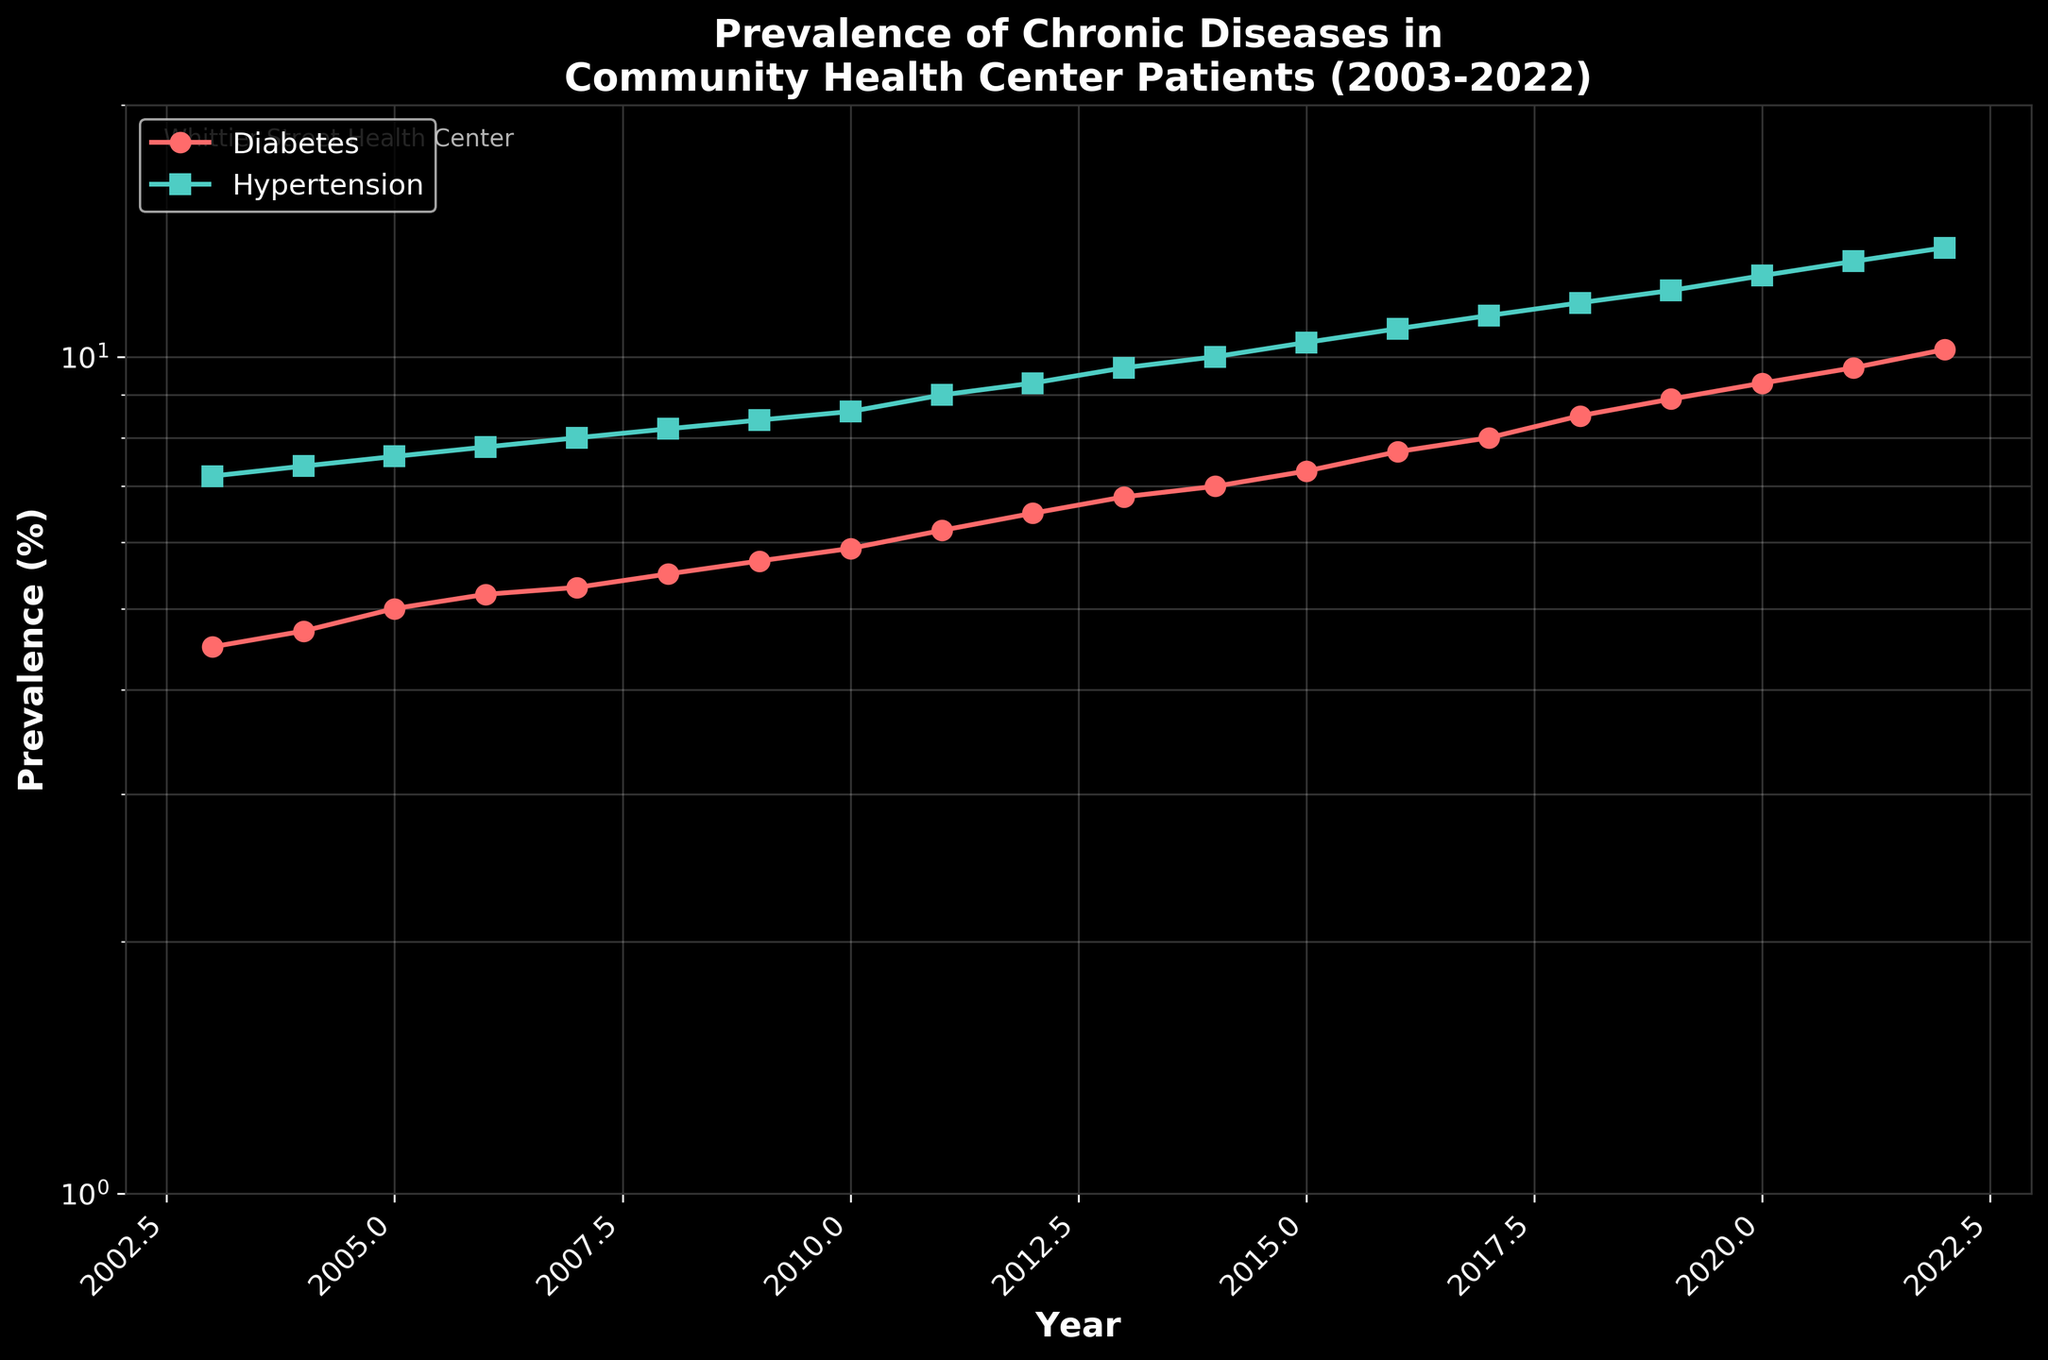What is the title of the figure? The title is usually displayed at the top of the figure and provides a summary of the content. In this case, it reads "Prevalence of Chronic Diseases in Community Health Center Patients (2003-2022)".
Answer: Prevalence of Chronic Diseases in Community Health Center Patients (2003-2022) What are the y-axis units? The y-axis represents the prevalence of chronic diseases and is labeled as "Prevalence (%)". This is clearly indicated along the axis.
Answer: Prevalence (%) What is the color of the line representing diabetes prevalence? The color of the lines is differentiated to easily distinguish between the two conditions. The line representing diabetes prevalence is red.
Answer: Red By how much did the prevalence of diabetes increase from 2003 to 2022? To find the increase, subtract the 2003 value from the 2022 value. The diabetes prevalence in 2003 was 4.5%, and in 2022 it was 10.2%. The increase is 10.2% - 4.5% = 5.7%.
Answer: 5.7% In which year did the prevalence of hypertension exceed 10%? Look at the line representing hypertension and identify the year where it first exceeds 10%. In this case, it exceeds 10% in the year 2014.
Answer: 2014 Compare the rate of increase for diabetes and hypertension between 2003 and 2013. Which condition increased more rapidly? Calculate the increase for both from 2003 to 2013: Diabetes increased from 4.5% to 6.8% (6.8% - 4.5% = 2.3%), and Hypertension increased from 7.2% to 9.7% (9.7% - 7.2% = 2.5%). Hypertension had a slightly higher increase.
Answer: Hypertension What is the average prevalence of diabetes over the 20-year period? Sum the diabetes prevalences from 2003 to 2022 and divide by the number of years. The prevalences are [4.5, 4.7, 5.0, 5.2, 5.3, 5.5, 5.7, 5.9, 6.2, 6.5, 6.8, 7.0, 7.3, 7.7, 8.0, 8.5, 8.9, 9.3, 9.7, 10.2]. Sum them to get 137.2, then divide by 20: 137.2 / 20 = 6.86%.
Answer: 6.86% Identify the year with the smallest relative year-on-year increase in hypertension prevalence. Examine the hypertension prevalence for each consecutive pair of years and find the smallest relative increase. The smallest increase is from 2006 to 2007 (0.2 percentage points, from 7.8% to 8.0%).
Answer: 2006 to 2007 How much did the prevalence of hypertension change between 2010 and 2022? Subtract the prevalence in 2010 from the prevalence in 2022: 13.5% - 8.6% = 4.9%.
Answer: 4.9% Which condition had a more constant rate of increase over the 20-year period? By observing the two lines, the diabetes prevalence line has a more consistent and steady increase, while hypertension shows minor fluctuations.
Answer: Diabetes 